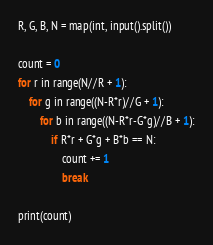Convert code to text. <code><loc_0><loc_0><loc_500><loc_500><_Python_>R, G, B, N = map(int, input().split())

count = 0
for r in range(N//R + 1):
    for g in range((N-R*r)//G + 1):
        for b in range((N-R*r-G*g)//B + 1):
            if R*r + G*g + B*b == N:
                count += 1
                break

print(count)
</code> 